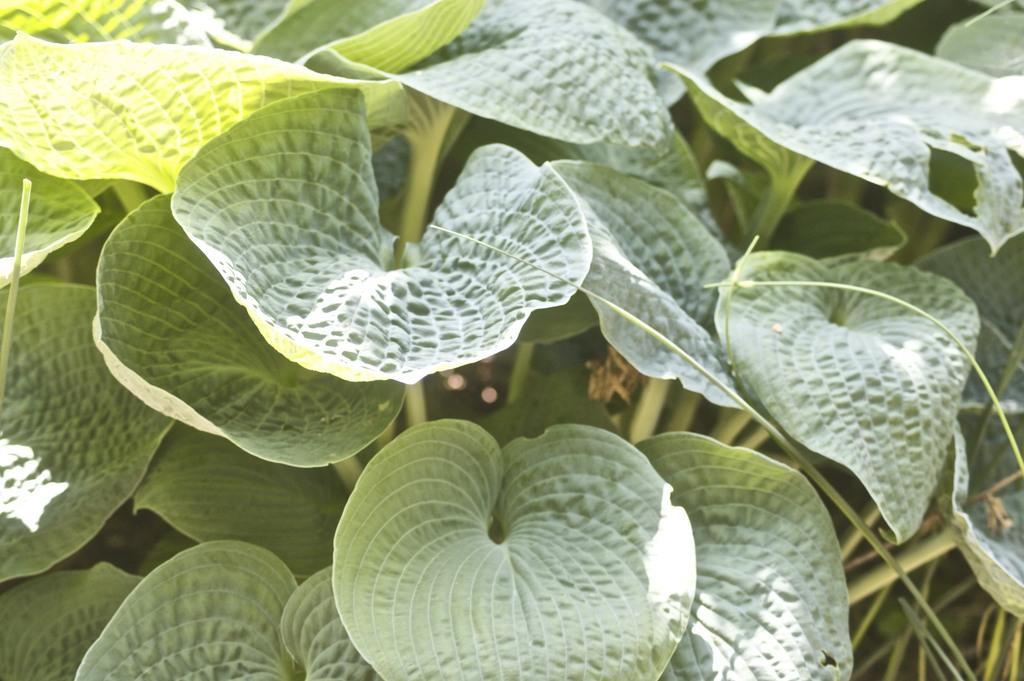Describe this image in one or two sentences. In this image I can see many leaves in green color. 